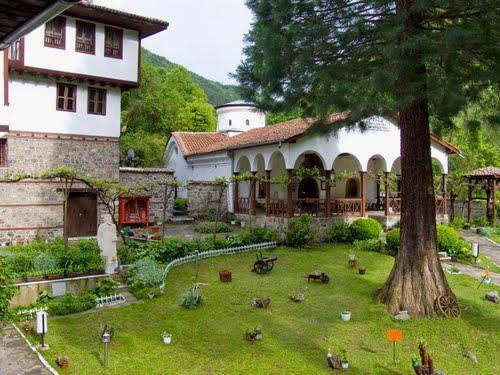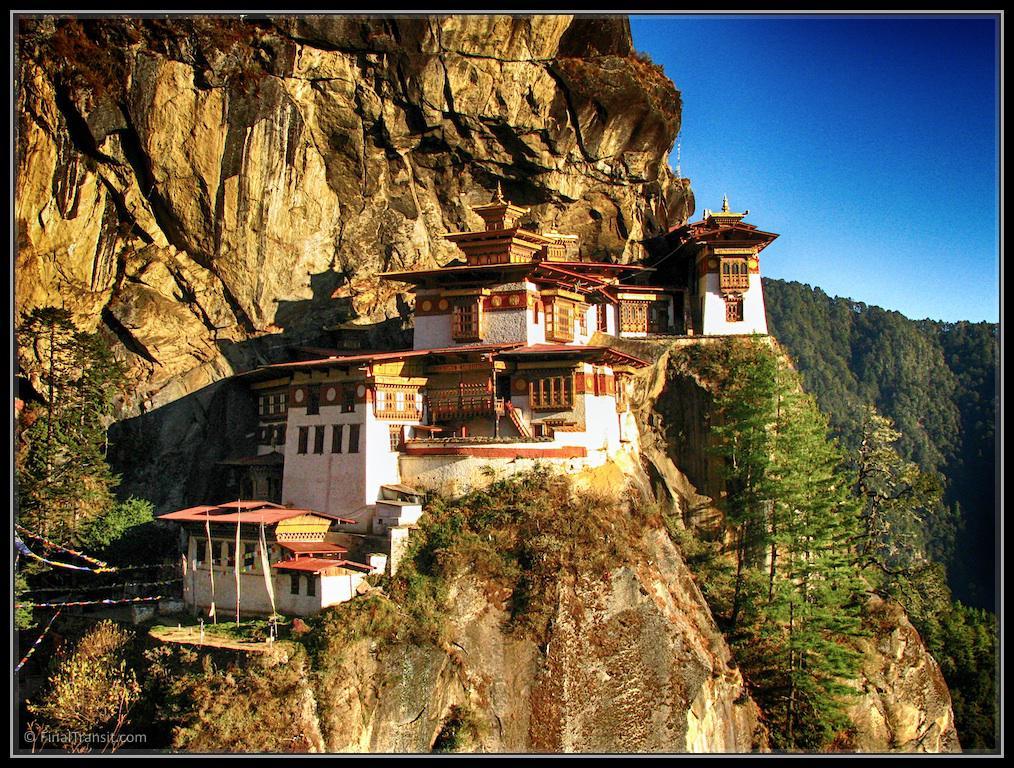The first image is the image on the left, the second image is the image on the right. Considering the images on both sides, is "At least one religious cross can be seen in one image." valid? Answer yes or no. No. The first image is the image on the left, the second image is the image on the right. Analyze the images presented: Is the assertion "A stone path with a cauldron-type item leads to a grand entrance of a temple in one image." valid? Answer yes or no. No. 